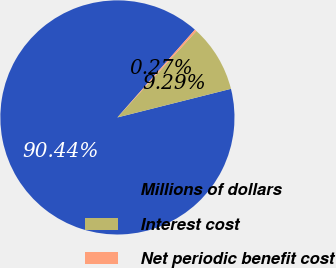Convert chart to OTSL. <chart><loc_0><loc_0><loc_500><loc_500><pie_chart><fcel>Millions of dollars<fcel>Interest cost<fcel>Net periodic benefit cost<nl><fcel>90.44%<fcel>9.29%<fcel>0.27%<nl></chart> 